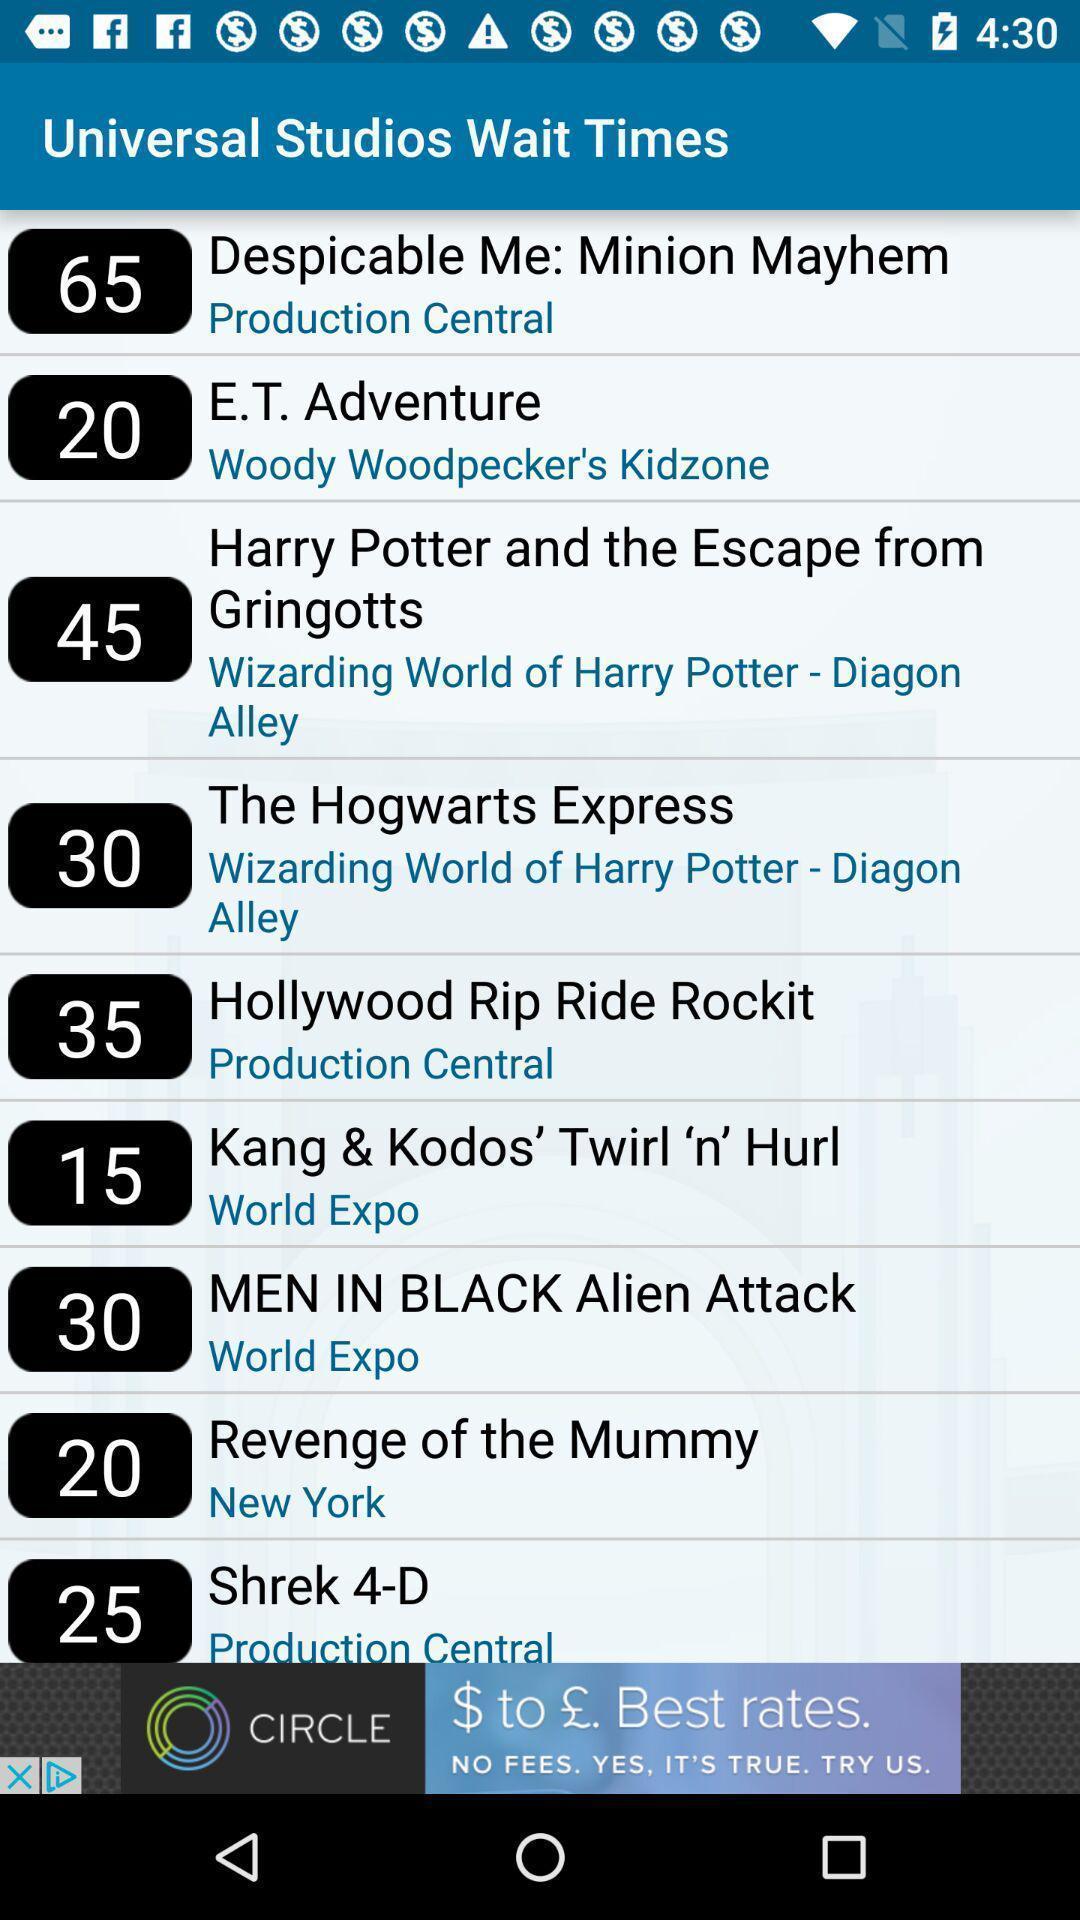Tell me about the visual elements in this screen capture. Screen shows several options. 